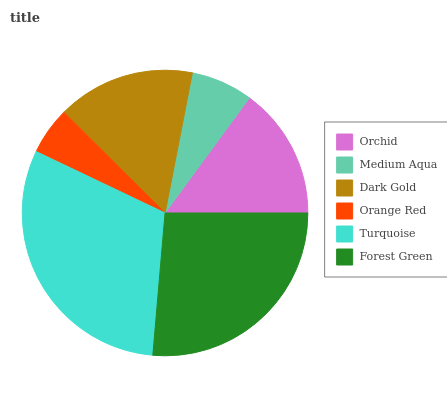Is Orange Red the minimum?
Answer yes or no. Yes. Is Turquoise the maximum?
Answer yes or no. Yes. Is Medium Aqua the minimum?
Answer yes or no. No. Is Medium Aqua the maximum?
Answer yes or no. No. Is Orchid greater than Medium Aqua?
Answer yes or no. Yes. Is Medium Aqua less than Orchid?
Answer yes or no. Yes. Is Medium Aqua greater than Orchid?
Answer yes or no. No. Is Orchid less than Medium Aqua?
Answer yes or no. No. Is Dark Gold the high median?
Answer yes or no. Yes. Is Orchid the low median?
Answer yes or no. Yes. Is Medium Aqua the high median?
Answer yes or no. No. Is Dark Gold the low median?
Answer yes or no. No. 